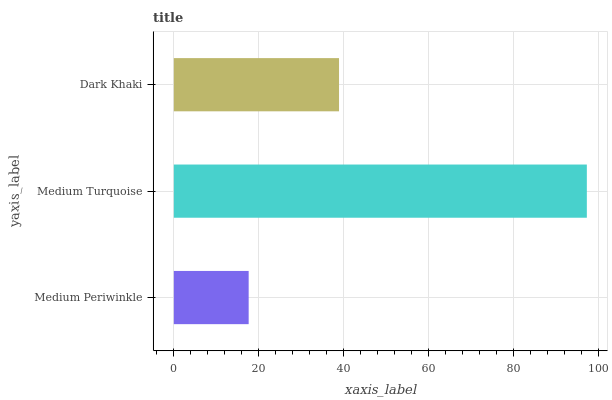Is Medium Periwinkle the minimum?
Answer yes or no. Yes. Is Medium Turquoise the maximum?
Answer yes or no. Yes. Is Dark Khaki the minimum?
Answer yes or no. No. Is Dark Khaki the maximum?
Answer yes or no. No. Is Medium Turquoise greater than Dark Khaki?
Answer yes or no. Yes. Is Dark Khaki less than Medium Turquoise?
Answer yes or no. Yes. Is Dark Khaki greater than Medium Turquoise?
Answer yes or no. No. Is Medium Turquoise less than Dark Khaki?
Answer yes or no. No. Is Dark Khaki the high median?
Answer yes or no. Yes. Is Dark Khaki the low median?
Answer yes or no. Yes. Is Medium Periwinkle the high median?
Answer yes or no. No. Is Medium Turquoise the low median?
Answer yes or no. No. 